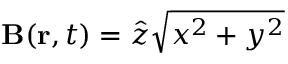<formula> <loc_0><loc_0><loc_500><loc_500>B ( r , t ) = \hat { z } \sqrt { x ^ { 2 } + y ^ { 2 } }</formula> 